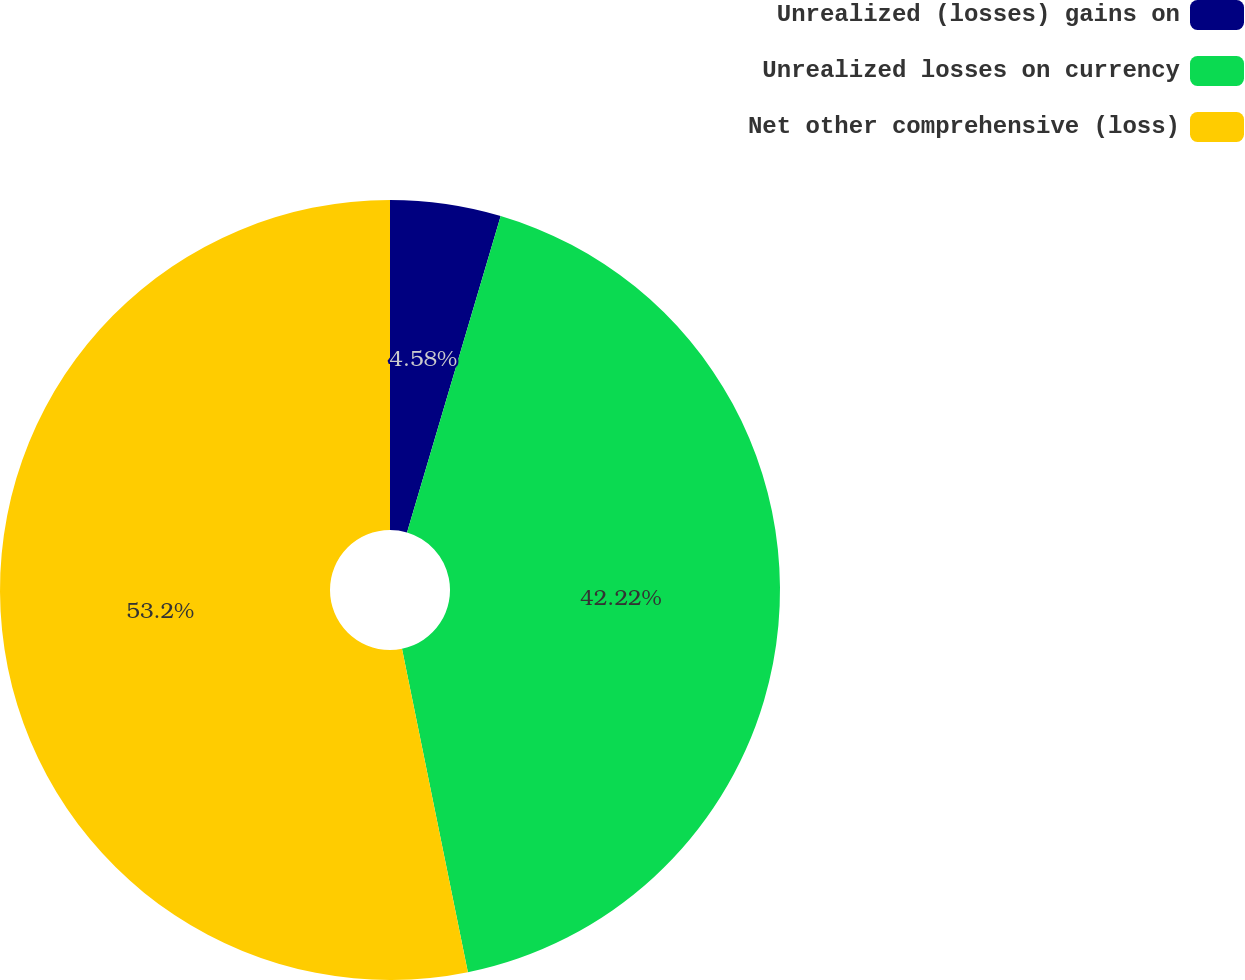<chart> <loc_0><loc_0><loc_500><loc_500><pie_chart><fcel>Unrealized (losses) gains on<fcel>Unrealized losses on currency<fcel>Net other comprehensive (loss)<nl><fcel>4.58%<fcel>42.22%<fcel>53.2%<nl></chart> 